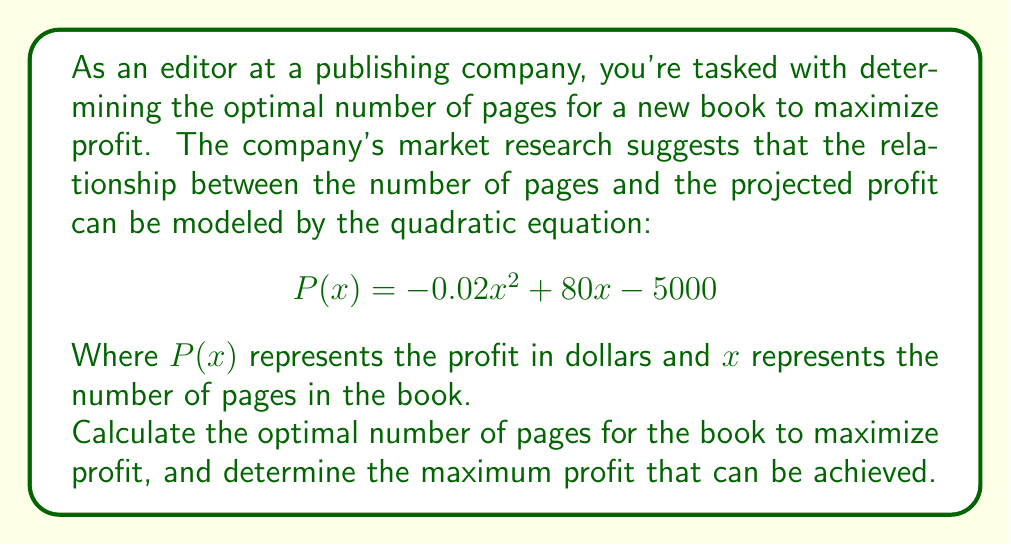Help me with this question. To solve this problem, we'll follow these steps:

1. Recognize that the given equation is in the form of a quadratic function:
   $$P(x) = -0.02x^2 + 80x - 5000$$

2. To find the maximum value of a quadratic function, we need to find the vertex of the parabola. The x-coordinate of the vertex represents the optimal number of pages, and the y-coordinate represents the maximum profit.

3. For a quadratic function in the form $f(x) = ax^2 + bx + c$, the x-coordinate of the vertex is given by the formula:
   $$x = -\frac{b}{2a}$$

4. In our case, $a = -0.02$ and $b = 80$. Let's substitute these values:
   $$x = -\frac{80}{2(-0.02)} = -\frac{80}{-0.04} = 2000$$

5. The optimal number of pages is 2000.

6. To find the maximum profit, we need to calculate $P(2000)$:

   $$\begin{align}
   P(2000) &= -0.02(2000)^2 + 80(2000) - 5000 \\
   &= -0.02(4,000,000) + 160,000 - 5000 \\
   &= -80,000 + 160,000 - 5000 \\
   &= 75,000
   \end{align}$$

Therefore, the maximum profit is $75,000.
Answer: The optimal number of pages is 2000, and the maximum profit is $75,000. 